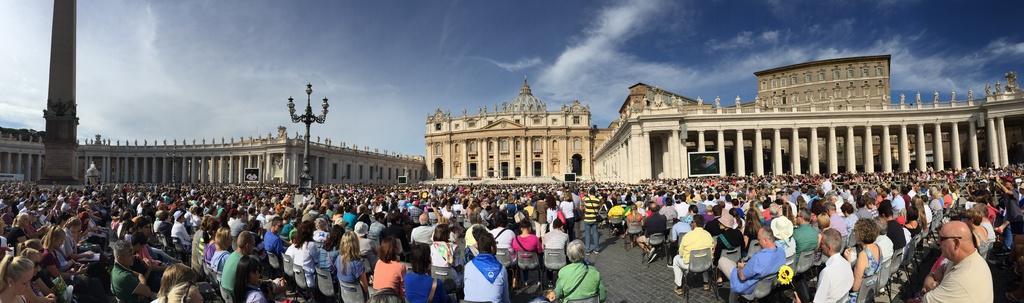Please provide a concise description of this image. In this image we can see a few people, among them some are standing on the floor and some are sitting on the chairs, in front of them there are some buildings, we can see there are some windows, pillars and lights, in the background we can see the sky with clouds. 